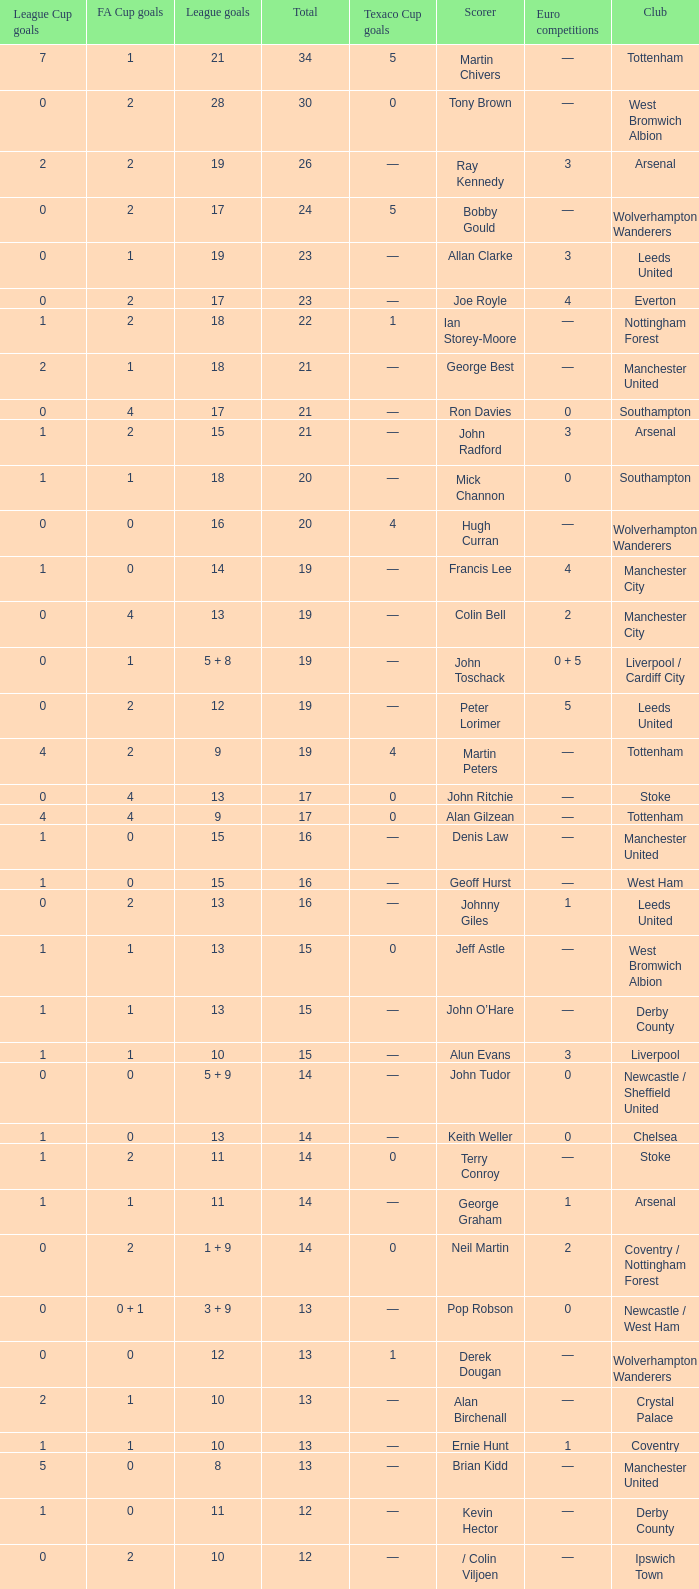What is FA Cup Goals, when Euro Competitions is 1, and when League Goals is 11? 1.0. 